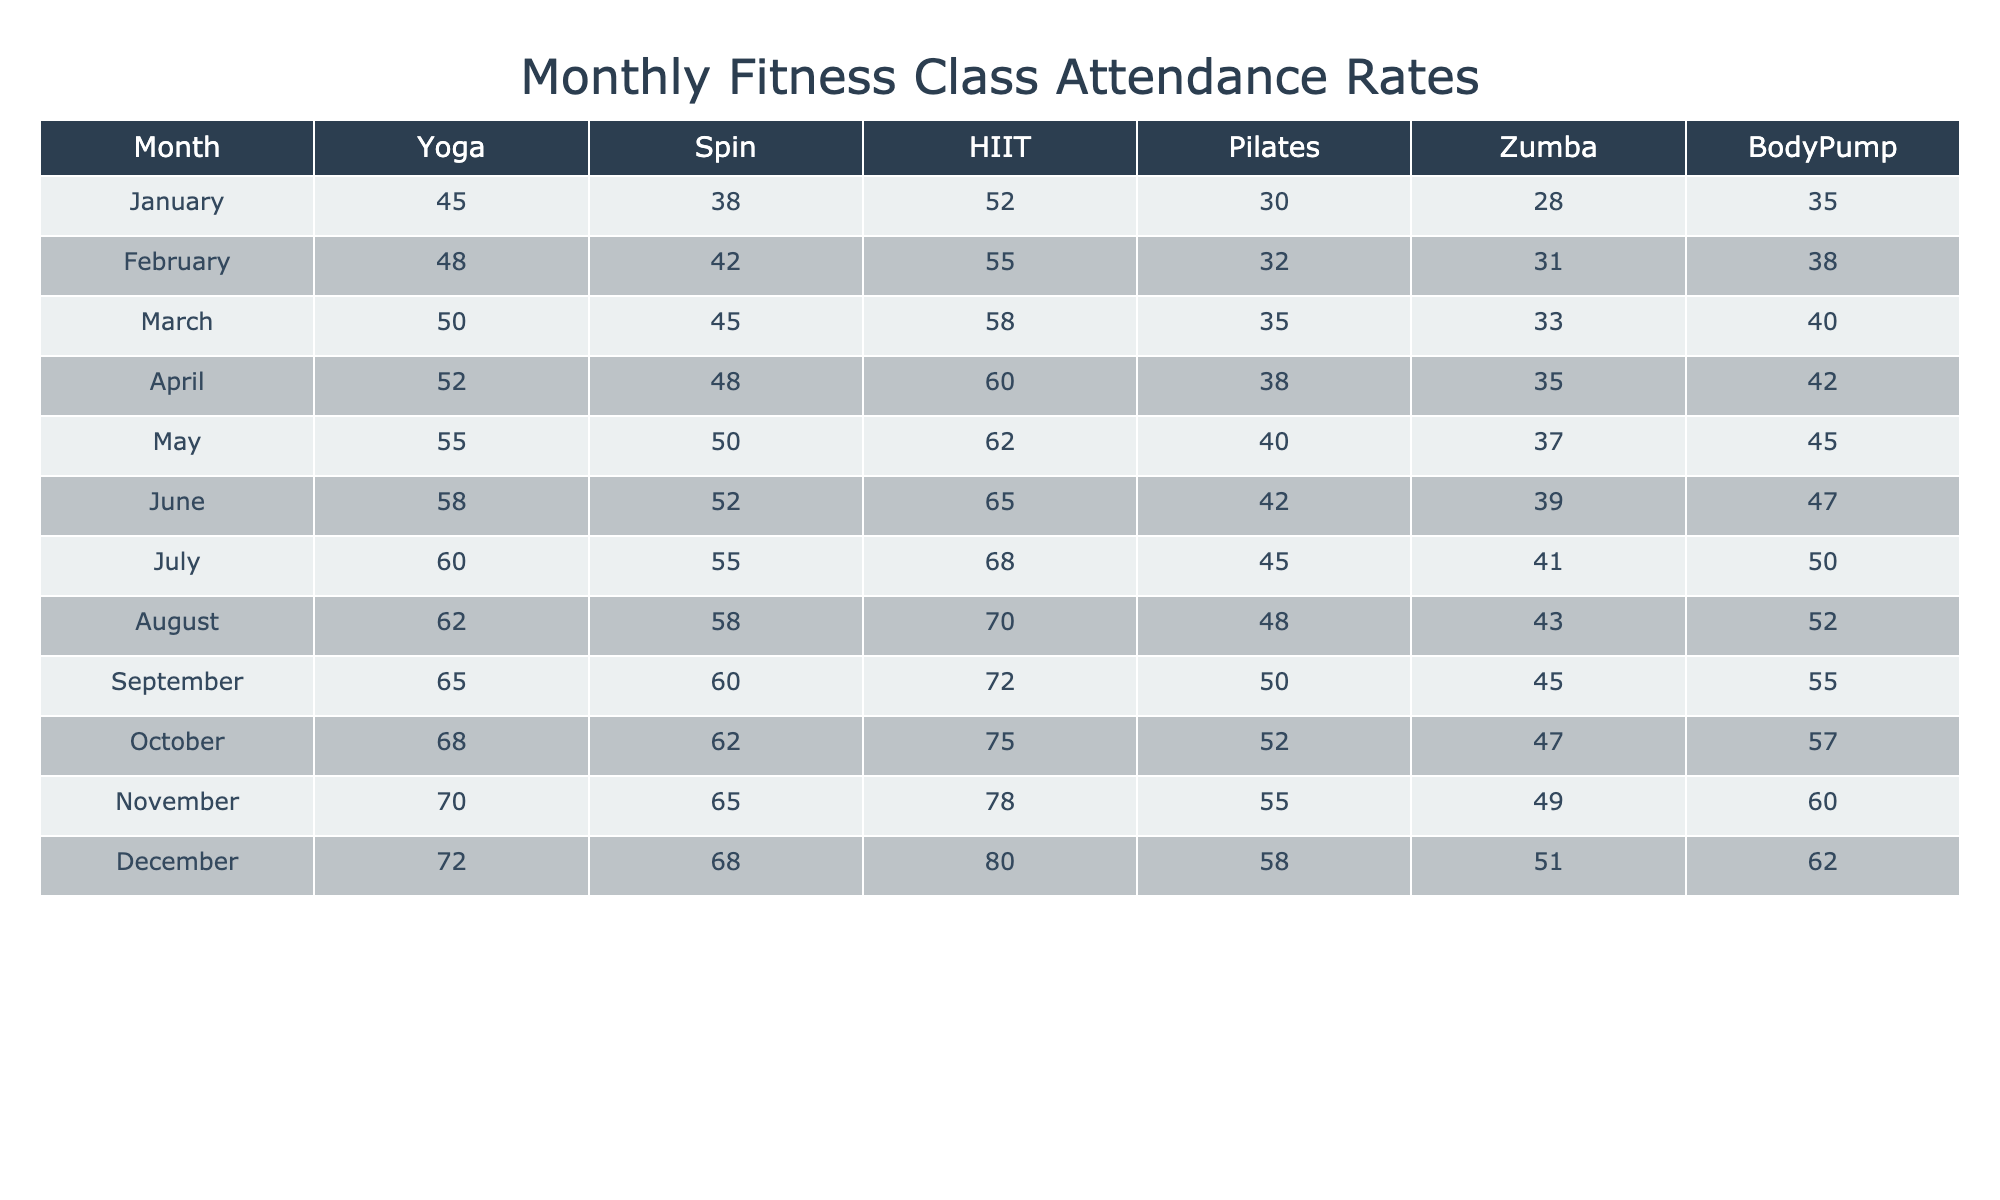What was the attendance rate for Spin classes in July? Referring to the table under the Spin column for July, the attendance rate is listed as 55.
Answer: 55 Which month had the highest attendance for Zumba classes? Looking through the Zumba column, December has the highest attendance listed at 51.
Answer: December What is the average attendance for Pilates classes throughout the year? To find the average attendance for Pilates, we sum the attendance values (30 + 32 + 35 + 38 + 40 + 42 + 45 + 48 + 50 + 52 + 55 + 58) =  609. Dividing by the number of months (12), the average is 609 / 12 = 50.75.
Answer: 50.75 Was the attendance for BodyPump classes higher in November than in June? In November, the attendance for BodyPump is 60, whereas in June it is 47. Since 60 is greater than 47, the answer is yes.
Answer: Yes Which fitness class had the largest increase in attendance from January to December? By comparing the January and December attendance rates for each class: Yoga (45 to 72, increase of 27), Spin (38 to 68, increase of 30), HIIT (52 to 80, increase of 28), Pilates (30 to 58, increase of 28), Zumba (28 to 51, increase of 23), and BodyPump (35 to 62, increase of 27). The largest increase is seen in Spin classes.
Answer: Spin What was the total attendance across all classes in October? To find the total attendance in October, we add the attendance rates for all classes: (68 + 62 + 75 + 52 + 47 + 57) = 361.
Answer: 361 Did more people attend Yoga or HIIT classes in August? In August, Yoga had an attendance of 62 and HIIT had 70. Since 70 is greater than 62, more people attended HIIT.
Answer: HIIT What is the difference in attendance between the Yoga classes in September and November? The attendance for Yoga in September is 65 and in November it is 70. The difference is 70 - 65 = 5.
Answer: 5 Is the attendance for Spin classes consistently increasing throughout the year? Reviewing the Spin column from January to December, the attendance figures are 38, 42, 45, 48, 50, 52, 55, 58, 60, 62, 65, 68, which shows a consistent increase each month.
Answer: Yes Calculate the total attendance from January to March for all classes combined. We first sum the attendance rates for each class for those months: January (45 + 38 + 52 + 30 + 28 + 35) = 228, February (48 + 42 + 55 + 32 + 31 + 38) = 246, March (50 + 45 + 58 + 35 + 33 + 40) = 261. The total for the three months combined is 228 + 246 + 261 = 735.
Answer: 735 